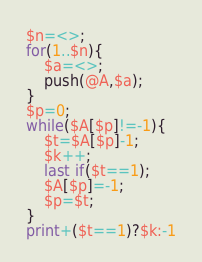<code> <loc_0><loc_0><loc_500><loc_500><_Perl_>$n=<>;
for(1..$n){
    $a=<>;
    push(@A,$a);
}
$p=0;
while($A[$p]!=-1){
    $t=$A[$p]-1;
    $k++;
    last if($t==1);
    $A[$p]=-1;
    $p=$t;
}
print+($t==1)?$k:-1</code> 